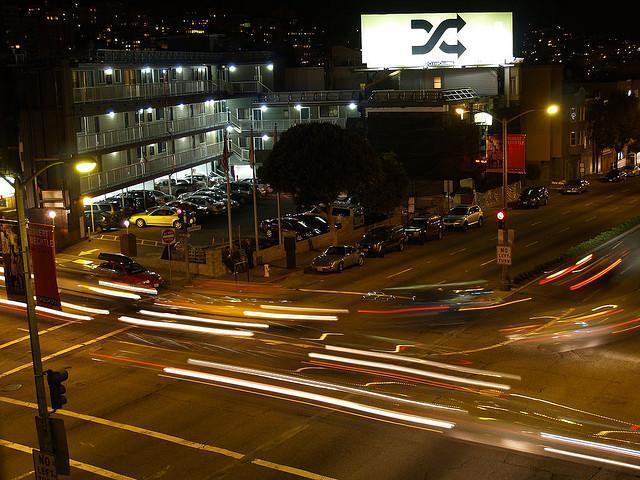How many buildings are visible?
Give a very brief answer. 2. 